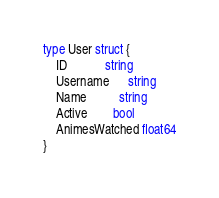<code> <loc_0><loc_0><loc_500><loc_500><_Go_>
type User struct {
	ID            string
	Username      string
	Name          string
	Active        bool
	AnimesWatched float64
}
</code> 